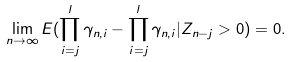Convert formula to latex. <formula><loc_0><loc_0><loc_500><loc_500>\lim _ { n \rightarrow \infty } E ( \prod _ { i = j } ^ { l } \gamma _ { n , i } - \prod _ { i = j } ^ { l } \gamma _ { n , i } | Z _ { n - j } > 0 ) = 0 .</formula> 